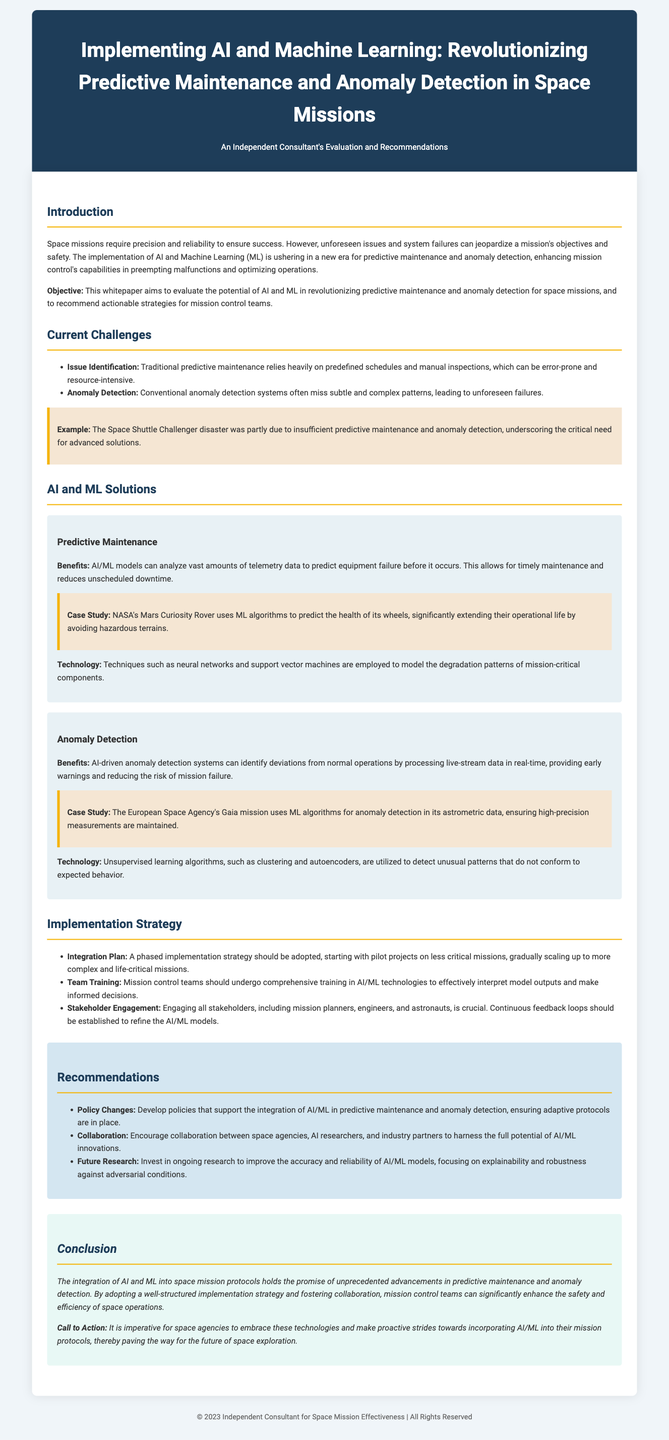What is the title of the whitepaper? The title of the whitepaper is presented in the header section of the document.
Answer: Implementing AI and Machine Learning: Revolutionizing Predictive Maintenance and Anomaly Detection in Space Missions What is the primary objective mentioned in the introduction? The objective is articulated clearly in the introductory section of the document.
Answer: To evaluate the potential of AI and ML in revolutionizing predictive maintenance and anomaly detection for space missions Which case study is cited in relation to predictive maintenance? A specific case study related to predictive maintenance is mentioned in the AI and ML Solutions section.
Answer: NASA's Mars Curiosity Rover What year is stated in the footer of the document? The footer contains the copyright year information at the bottom of the document.
Answer: 2023 What is one suggested implementation plan for AI/ML? Suggested strategies for implementation are listed in the Implementation Strategy section.
Answer: A phased implementation strategy What major challenge does traditional predictive maintenance face? The challenges are outlined in the Current Challenges section of the document.
Answer: Error-prone and resource-intensive Which technology is utilized for anomaly detection according to the whitepaper? The document specifies various technologies used for anomaly detection under the relevant subsections.
Answer: Unsupervised learning algorithms What does the conclusion emphasize about AI and ML in space missions? The conclusion summarizes the overarching benefits of the integration of these technologies in the closing section.
Answer: Unprecedented advancements in predictive maintenance and anomaly detection 